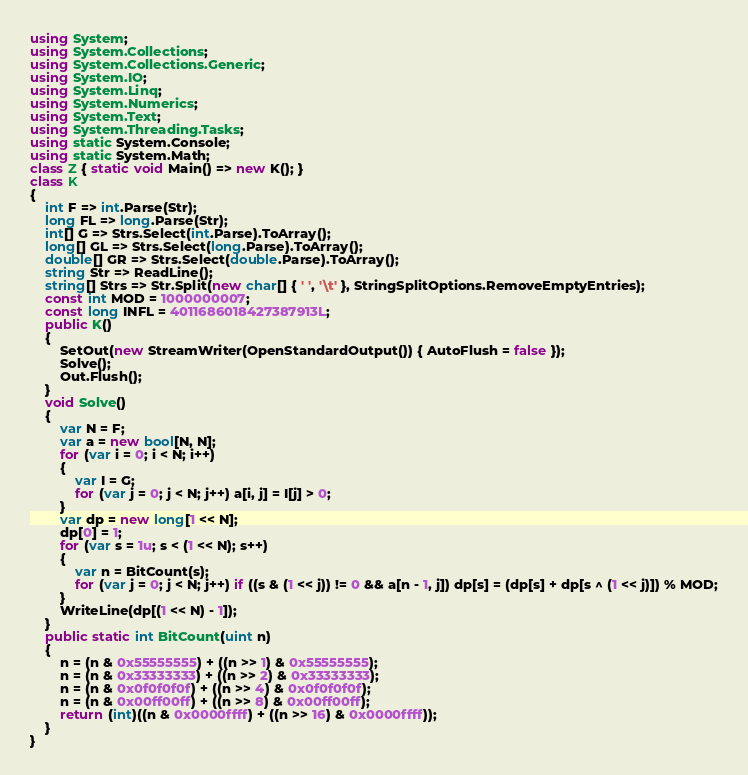<code> <loc_0><loc_0><loc_500><loc_500><_C#_>using System;
using System.Collections;
using System.Collections.Generic;
using System.IO;
using System.Linq;
using System.Numerics;
using System.Text;
using System.Threading.Tasks;
using static System.Console;
using static System.Math;
class Z { static void Main() => new K(); }
class K
{
	int F => int.Parse(Str);
	long FL => long.Parse(Str);
	int[] G => Strs.Select(int.Parse).ToArray();
	long[] GL => Strs.Select(long.Parse).ToArray();
	double[] GR => Strs.Select(double.Parse).ToArray();
	string Str => ReadLine();
	string[] Strs => Str.Split(new char[] { ' ', '\t' }, StringSplitOptions.RemoveEmptyEntries);
	const int MOD = 1000000007;
	const long INFL = 4011686018427387913L;
	public K()
	{
		SetOut(new StreamWriter(OpenStandardOutput()) { AutoFlush = false });
		Solve();
		Out.Flush();
	}
	void Solve()
	{
		var N = F;
		var a = new bool[N, N];
		for (var i = 0; i < N; i++)
		{
			var I = G;
			for (var j = 0; j < N; j++) a[i, j] = I[j] > 0;
		}
		var dp = new long[1 << N];
		dp[0] = 1;
		for (var s = 1u; s < (1 << N); s++)
		{
			var n = BitCount(s);
			for (var j = 0; j < N; j++) if ((s & (1 << j)) != 0 && a[n - 1, j]) dp[s] = (dp[s] + dp[s ^ (1 << j)]) % MOD;
		}
		WriteLine(dp[(1 << N) - 1]);
	}
	public static int BitCount(uint n)
	{
		n = (n & 0x55555555) + ((n >> 1) & 0x55555555);
		n = (n & 0x33333333) + ((n >> 2) & 0x33333333);
		n = (n & 0x0f0f0f0f) + ((n >> 4) & 0x0f0f0f0f);
		n = (n & 0x00ff00ff) + ((n >> 8) & 0x00ff00ff);
		return (int)((n & 0x0000ffff) + ((n >> 16) & 0x0000ffff));
	}
}
</code> 